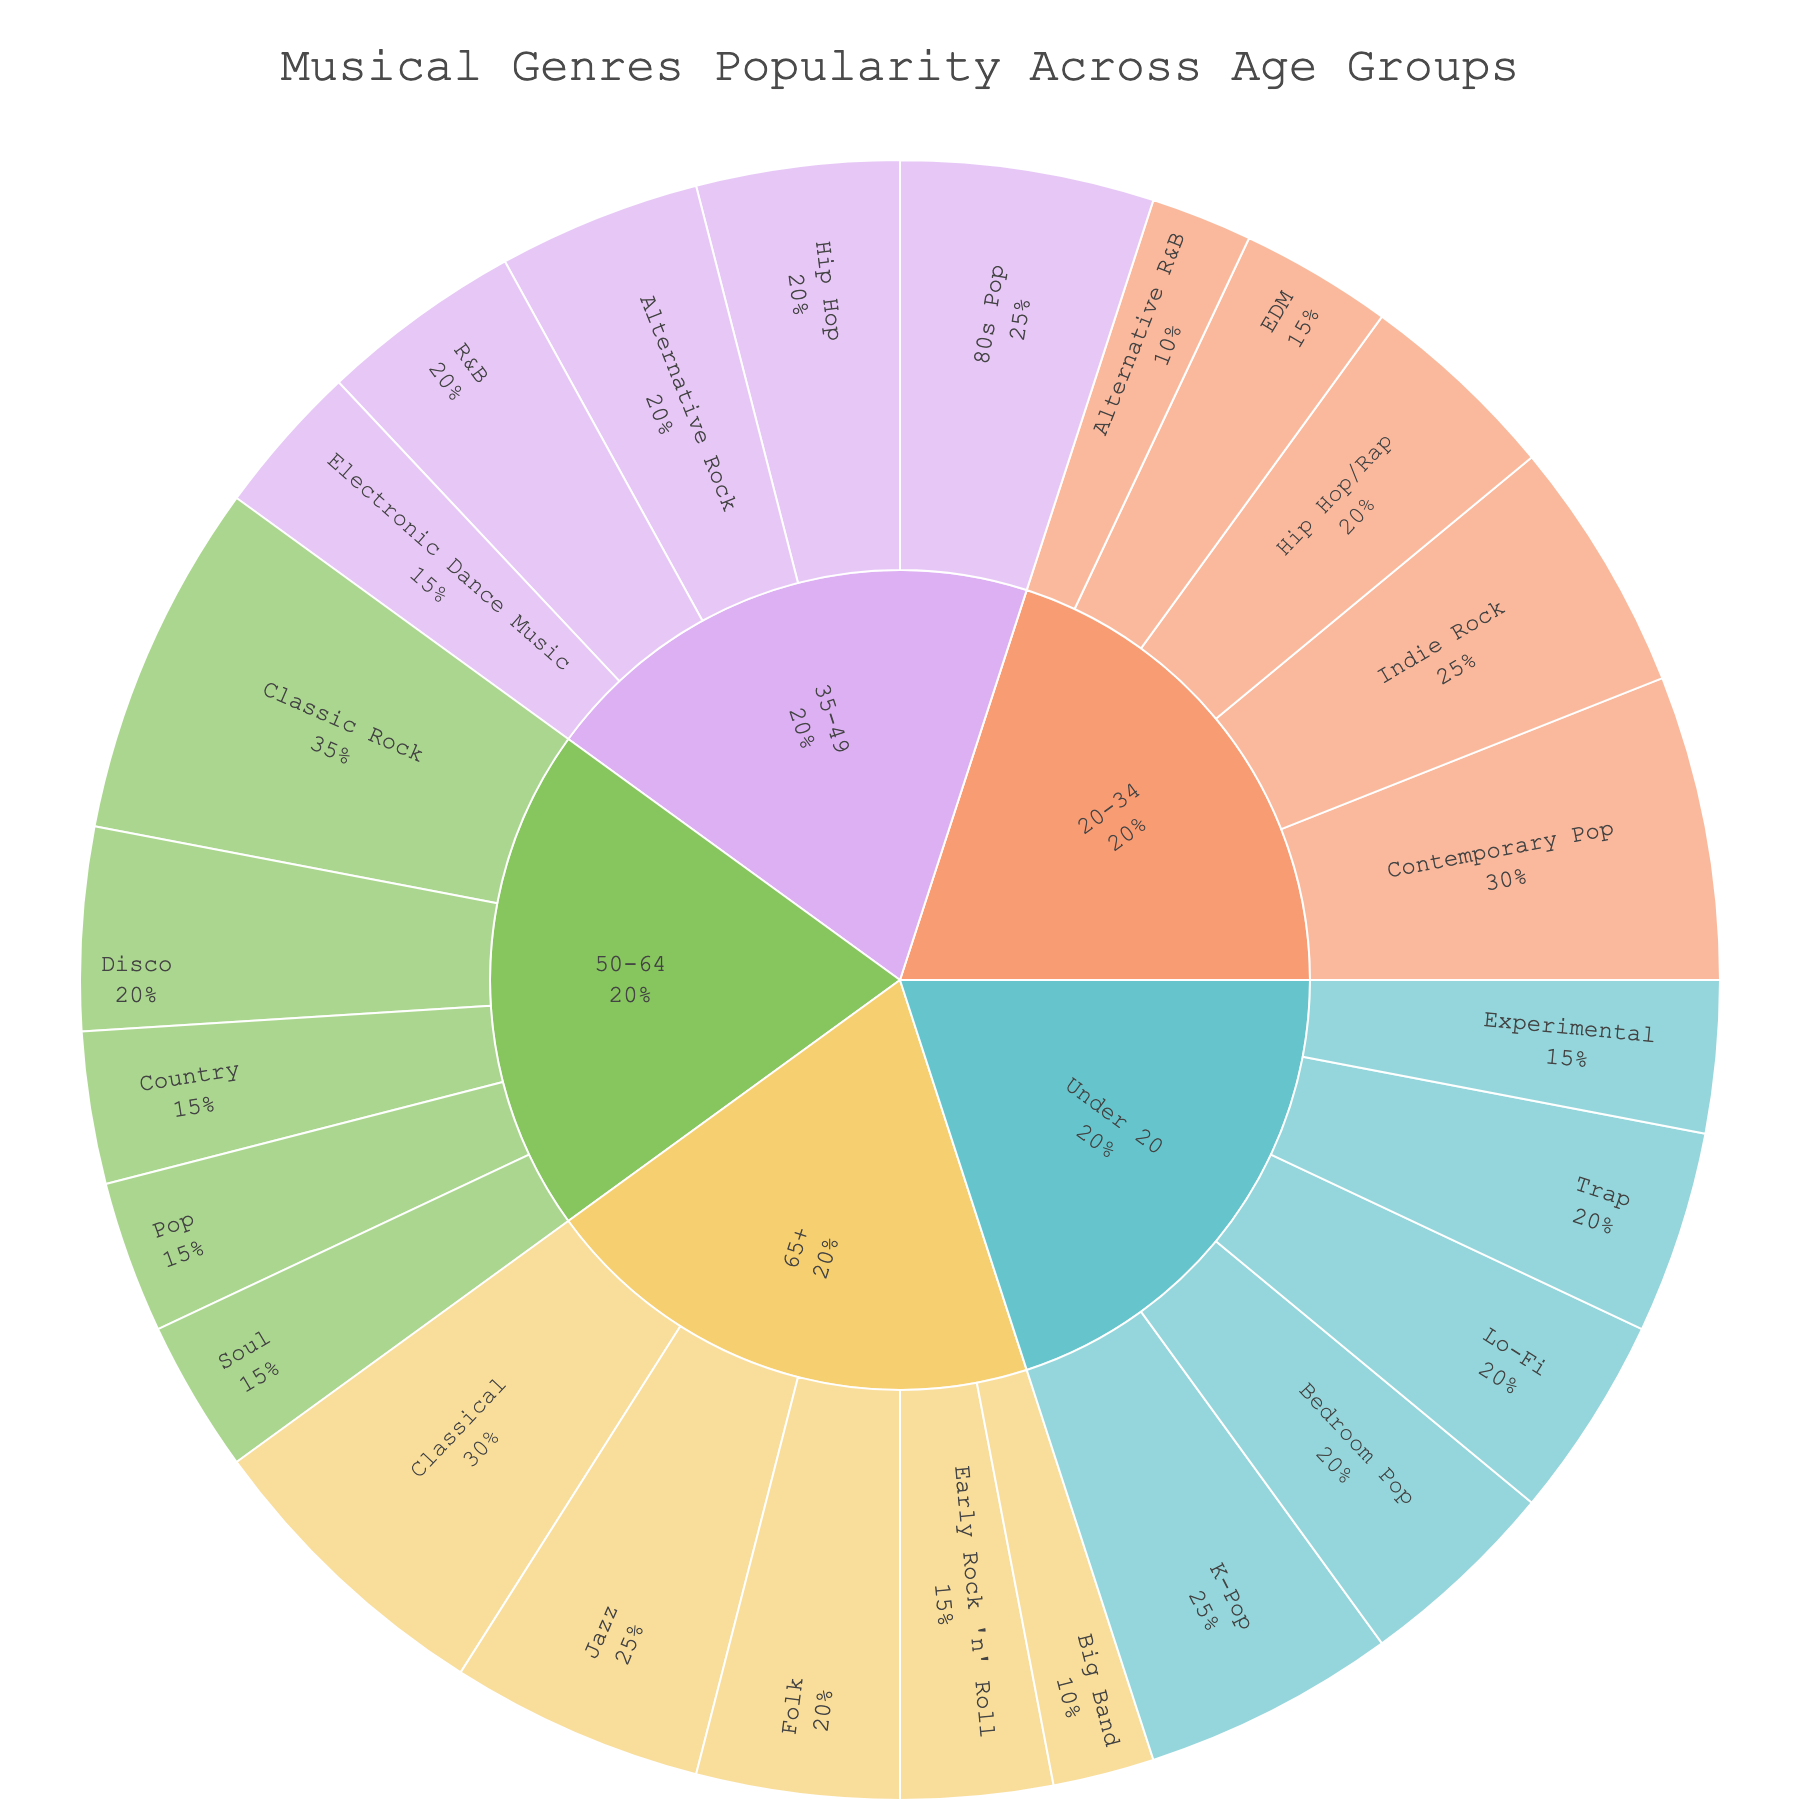What is the most popular musical genre among people aged 50-64? Refer to the section of the sunburst chart corresponding to the age group 50-64 and identify the genre with the largest segment. Classic Rock has the largest percentage.
Answer: Classic Rock Comparing people under 20 and those aged 20-34, which age group has a higher percentage for Hip Hop-related genres? Sum the percentages for Hip Hop (Trap) for Under 20 and Hip Hop/Rap for 20-34. Under 20 has 20% (Trap) and 20-34 has 20% (Hip Hop/Rap). Both age groups have the same percentage.
Answer: Equal Which age group has the broadest variety of musical genres represented? Count the number of different genres listed for each age group in the sunburst chart. The age group 'Under 20' has the most diverse genres listed.
Answer: Under 20 What percentage of the 65+ age group prefers Folk music? Refer to the segment for the age group 65+ and locate the percentage associated with Folk music. The segment shows a percentage of 20.
Answer: 20% Comparing Jazz in the 65+ age group to Indie Rock in the 20-34 age group, which genre is more popular? Identify the percentages of Jazz (25%) for 65+ and Indie Rock (25%) for 20-34. Both genres have the same popularity.
Answer: Equal What is the combined percentage for Pop-related genres (Pop, Contemporary Pop, etc.) for all age groups? Add the percentages for Pop (50-64), Contemporary Pop (20-34), 80s Pop (35-49), and Bedroom Pop (Under 20). So the calculation is 15 + 30 + 25 + 20 = 90.
Answer: 90% Which age group shows the highest preference for Classical music? Locate the segment for Classical music in different age groups. 65+ age group has the highest preference at 30%.
Answer: 65+ Which genre segment holds the smallest percentage in any age group? Scan for the smallest percentage values across all segments in the chart. Big Band in the 65+ age group is the smallest with 10%.
Answer: Big Band How many age groups have Jazz as one of their popular genres? Identify age groups where Jazz appears in the sunburst chart. Only the 65+ age group has Jazz listed.
Answer: One What is the combined percentage of genres preferring electronic-associated music (EDM, Electronic Dance Music, Lo-Fi) across all age groups? Sum the percentages of EDM (20-34), Electronic Dance Music (35-49), and Lo-Fi (Under 20). So the calculation is 15 + 15 + 20 = 50.
Answer: 50% 